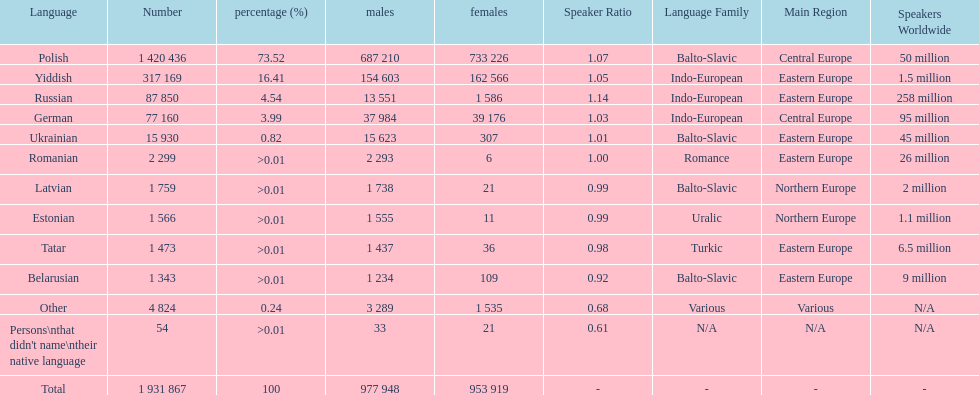Can you give me this table as a dict? {'header': ['Language', 'Number', 'percentage (%)', 'males', 'females', 'Speaker Ratio', 'Language Family', 'Main Region', 'Speakers Worldwide'], 'rows': [['Polish', '1 420 436', '73.52', '687 210', '733 226', '1.07', 'Balto-Slavic', 'Central Europe', '50 million'], ['Yiddish', '317 169', '16.41', '154 603', '162 566', '1.05', 'Indo-European', 'Eastern Europe', '1.5 million'], ['Russian', '87 850', '4.54', '13 551', '1 586', '1.14', 'Indo-European', 'Eastern Europe', '258 million'], ['German', '77 160', '3.99', '37 984', '39 176', '1.03', 'Indo-European', 'Central Europe', '95 million'], ['Ukrainian', '15 930', '0.82', '15 623', '307', '1.01', 'Balto-Slavic', 'Eastern Europe', '45 million'], ['Romanian', '2 299', '>0.01', '2 293', '6', '1.00', 'Romance', 'Eastern Europe', '26 million'], ['Latvian', '1 759', '>0.01', '1 738', '21', '0.99', 'Balto-Slavic', 'Northern Europe', '2 million'], ['Estonian', '1 566', '>0.01', '1 555', '11', '0.99', 'Uralic', 'Northern Europe', '1.1 million'], ['Tatar', '1 473', '>0.01', '1 437', '36', '0.98', 'Turkic', 'Eastern Europe', '6.5 million'], ['Belarusian', '1 343', '>0.01', '1 234', '109', '0.92', 'Balto-Slavic', 'Eastern Europe', '9 million'], ['Other', '4 824', '0.24', '3 289', '1 535', '0.68', 'Various', 'Various', 'N/A'], ["Persons\\nthat didn't name\\ntheir native language", '54', '>0.01', '33', '21', '0.61', 'N/A', 'N/A', 'N/A'], ['Total', '1 931 867', '100', '977 948', '953 919', '-', '-', '-', '-']]} The least amount of females Romanian. 